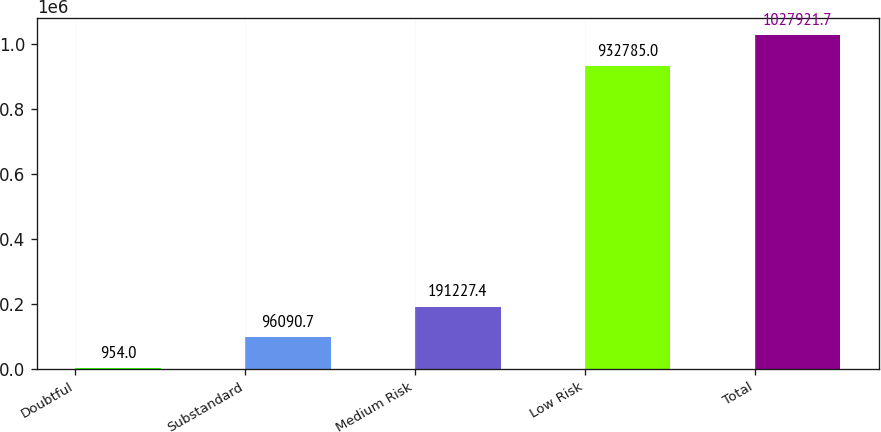Convert chart. <chart><loc_0><loc_0><loc_500><loc_500><bar_chart><fcel>Doubtful<fcel>Substandard<fcel>Medium Risk<fcel>Low Risk<fcel>Total<nl><fcel>954<fcel>96090.7<fcel>191227<fcel>932785<fcel>1.02792e+06<nl></chart> 